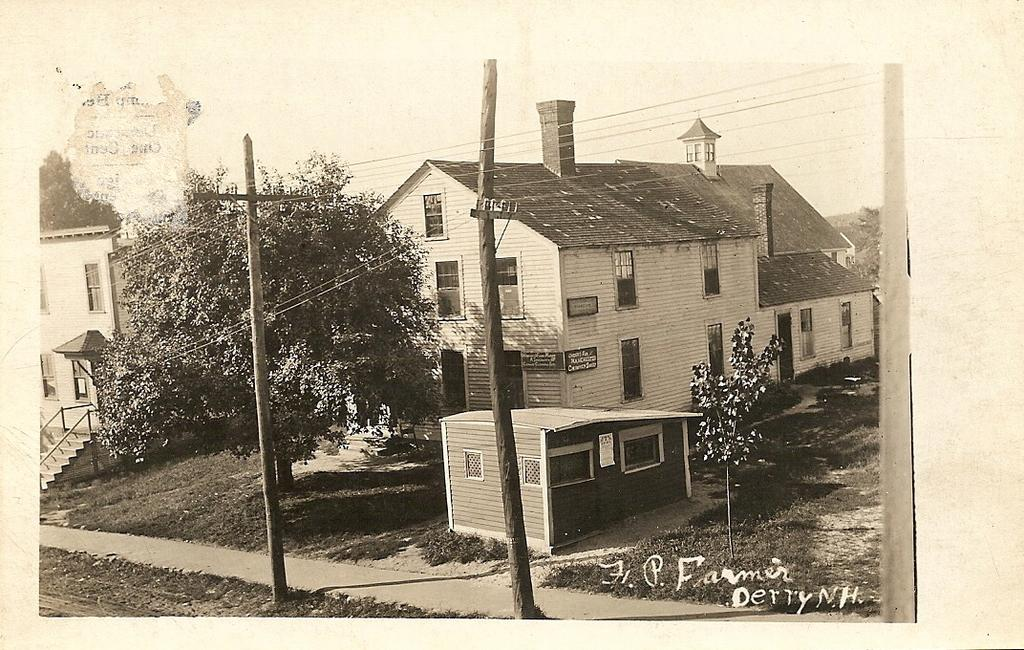What is featured on the poster in the image? The poster contains a building and trees. Can you describe the building depicted on the poster? Unfortunately, the provided facts do not give any details about the building on the poster. What else is present in the image besides the poster? The facts provided do not mention any other objects or elements in the image. What type of oven is used to cook the chicken in the image? There is no oven or chicken present in the image; it only features a poster with a building and trees. 